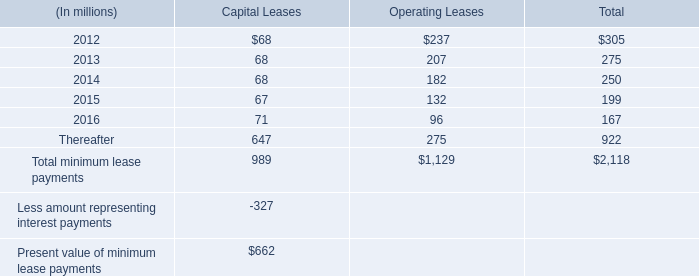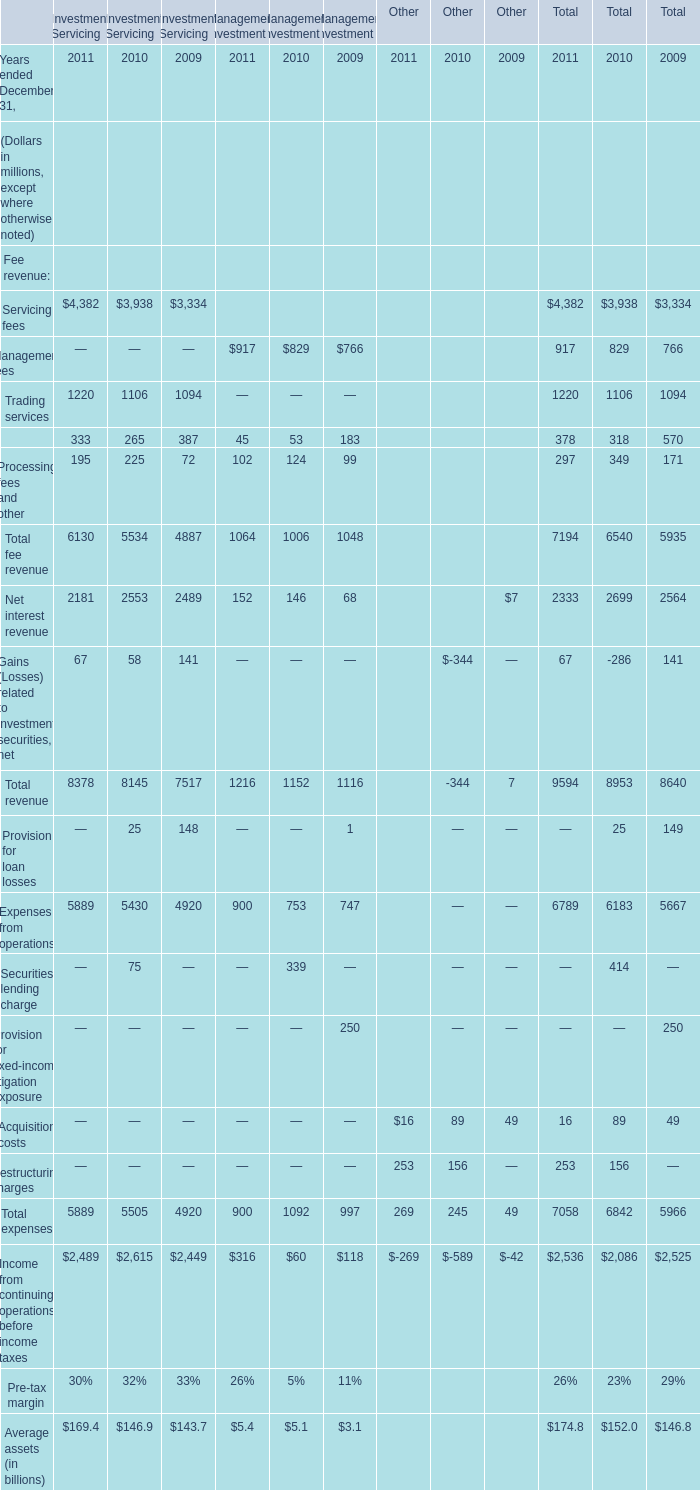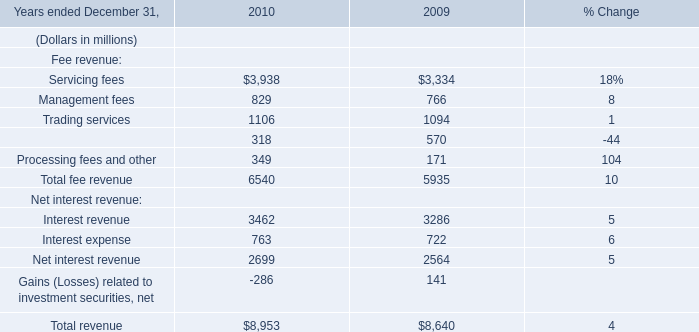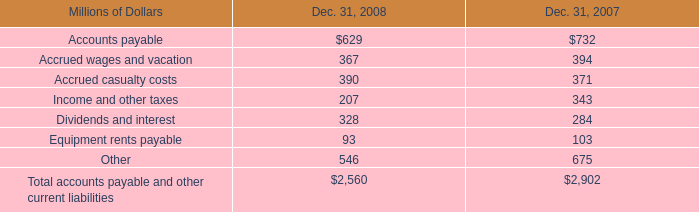Which year is Servicing fees greater than 1 in Investment Servicing 
Answer: 2011 2010 2009. 